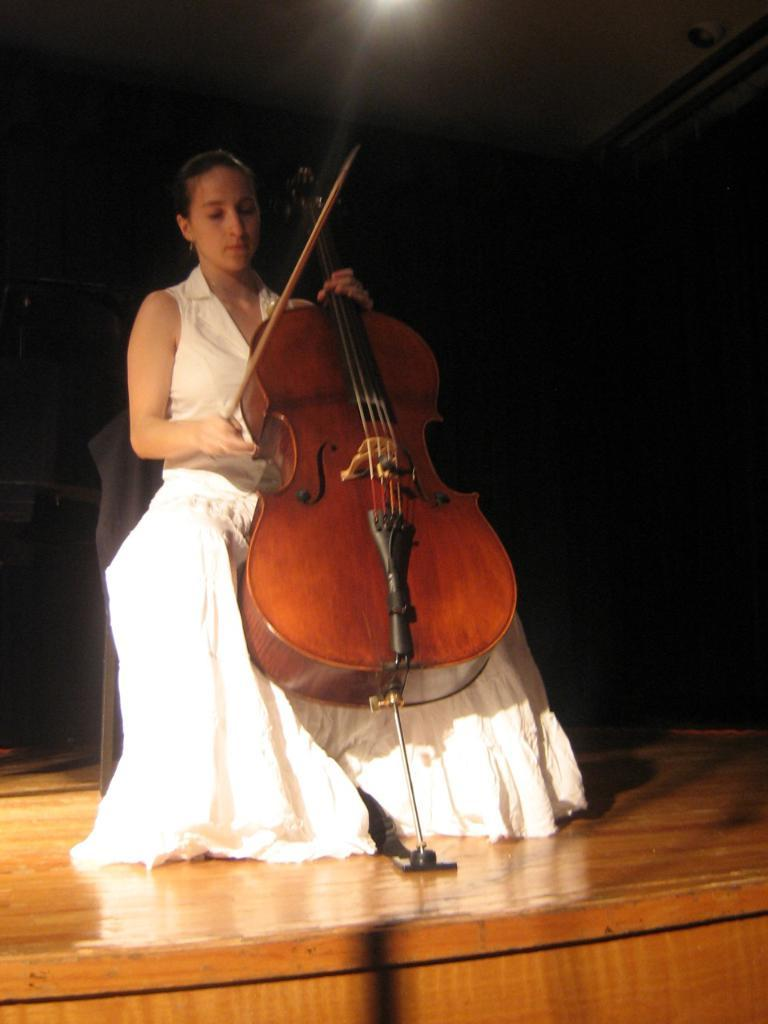What is the main subject of the image? The main subject of the image is a woman. What is the woman doing in the image? The woman is sitting in the image. What object is the woman holding? The woman is holding a violin. What type of button is the woman using to play the violin in the image? There is no button present in the image, and the woman is not using any button to play the violin. How many girls are visible in the image? There is only one woman visible in the image, not a group of girls. 